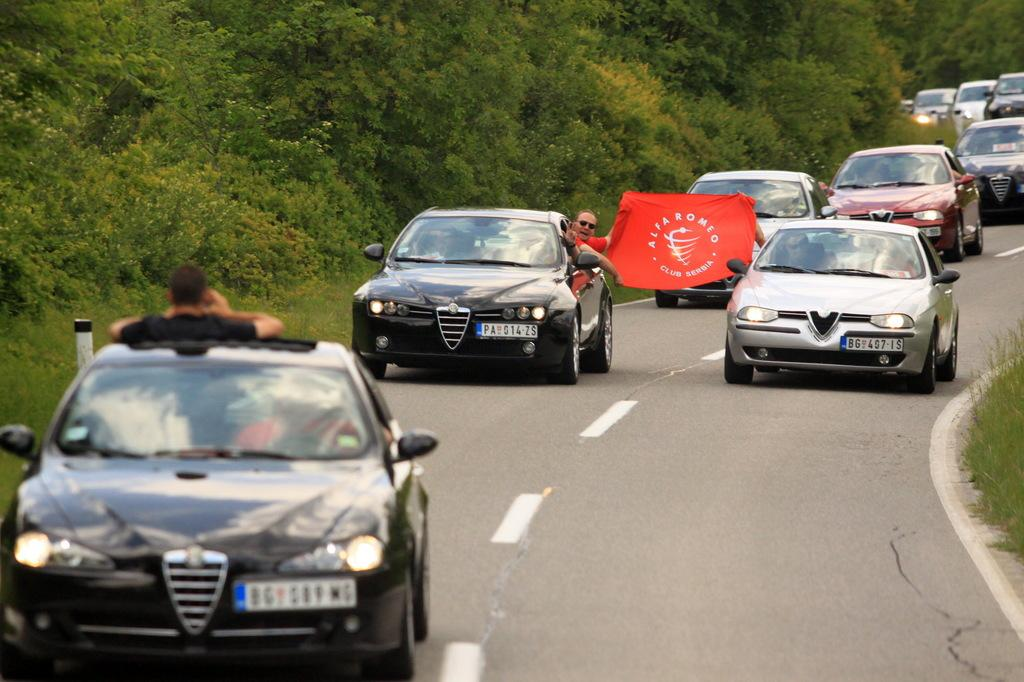What can be seen in the foreground of the picture? In the foreground of the picture, there are cars, a flag, people, and grass. What is the position of the flag in the picture? The flag is in the foreground of the picture. Can you describe the people in the foreground of the picture? There are people in the foreground of the picture, but their specific actions or appearances are not mentioned in the facts. What is visible in the background of the picture? In the background of the picture, there are trees and cars. Can you tell me how many robins are perched on the flag in the image? There are no robins present in the image; the flag is accompanied by cars, people, and grass in the foreground. What type of arm is holding the flag in the image? There is no arm holding the flag in the image; the flag is simply present in the foreground. 